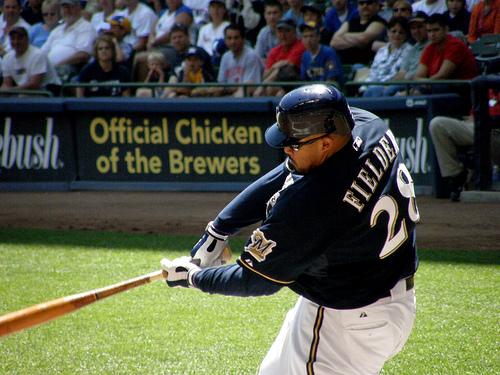Is the player wearing a helmet?
Quick response, please. Yes. What team does this man play for?
Concise answer only. Brewers. Is this a professional game?
Short answer required. Yes. 